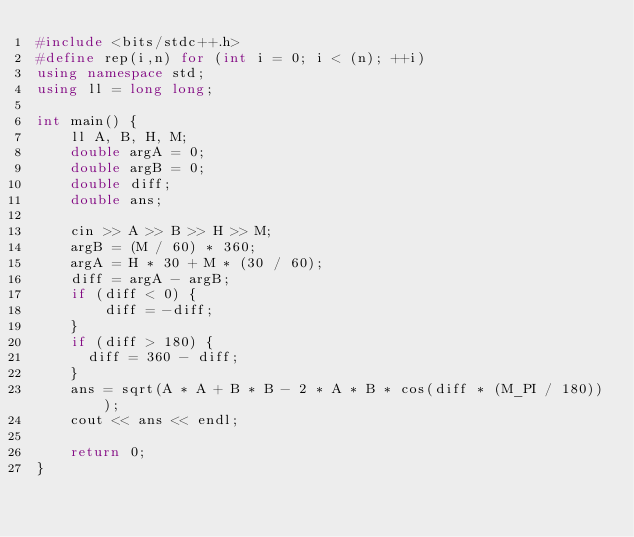<code> <loc_0><loc_0><loc_500><loc_500><_C++_>#include <bits/stdc++.h>
#define rep(i,n) for (int i = 0; i < (n); ++i)
using namespace std;
using ll = long long;

int main() {
    ll A, B, H, M;
    double argA = 0;
    double argB = 0;
    double diff;
    double ans;

    cin >> A >> B >> H >> M;
    argB = (M / 60) * 360;
    argA = H * 30 + M * (30 / 60);
    diff = argA - argB;
    if (diff < 0) {
        diff = -diff;
    }
  	if (diff > 180) {
      diff = 360 - diff;
    }
    ans = sqrt(A * A + B * B - 2 * A * B * cos(diff * (M_PI / 180)));
    cout << ans << endl;
    
    return 0;
}
</code> 